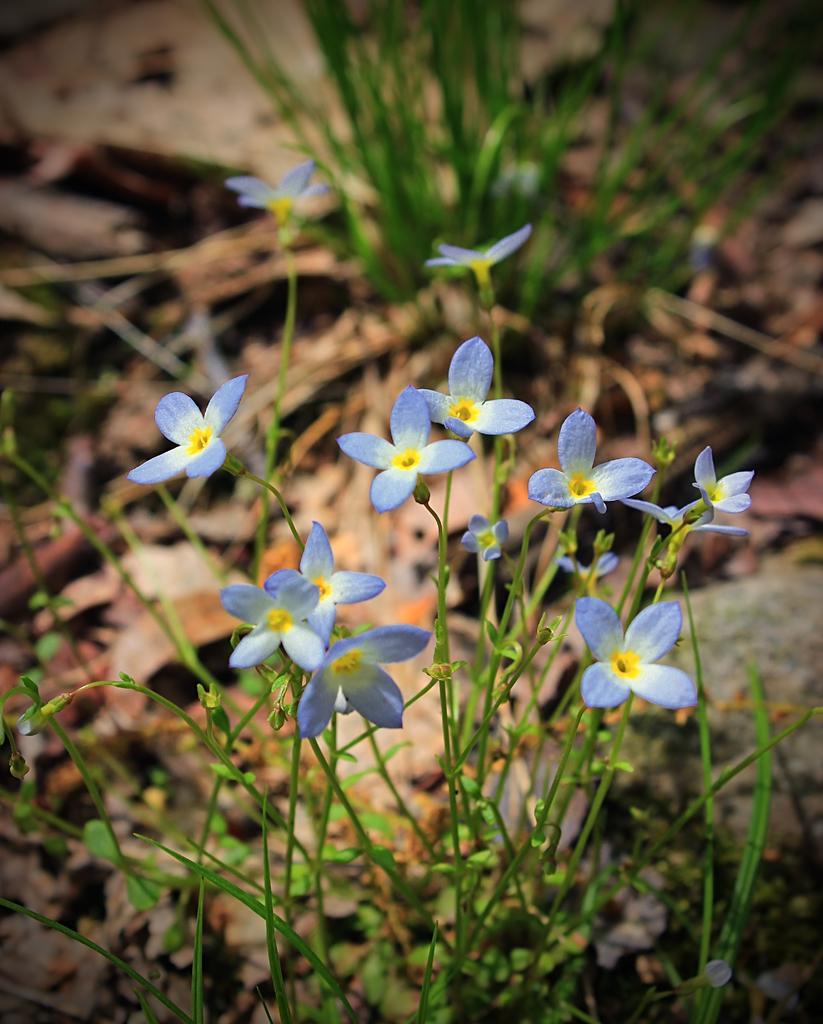In one or two sentences, can you explain what this image depicts? In this image there are plants and grass on the ground. In the foreground there are flowers to the stems. The background is blurry. 